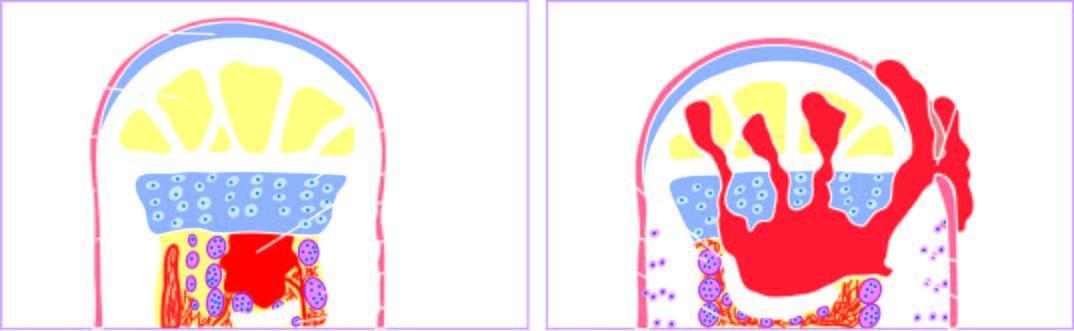what is the formation of viable new reactive bone surrounding the sequestrum called?
Answer the question using a single word or phrase. Involucrum 